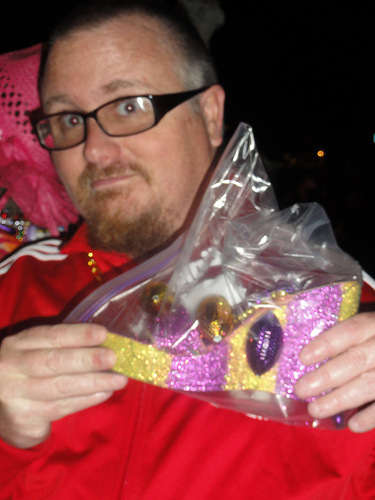<image>
Is the shoe in the bag? Yes. The shoe is contained within or inside the bag, showing a containment relationship. 